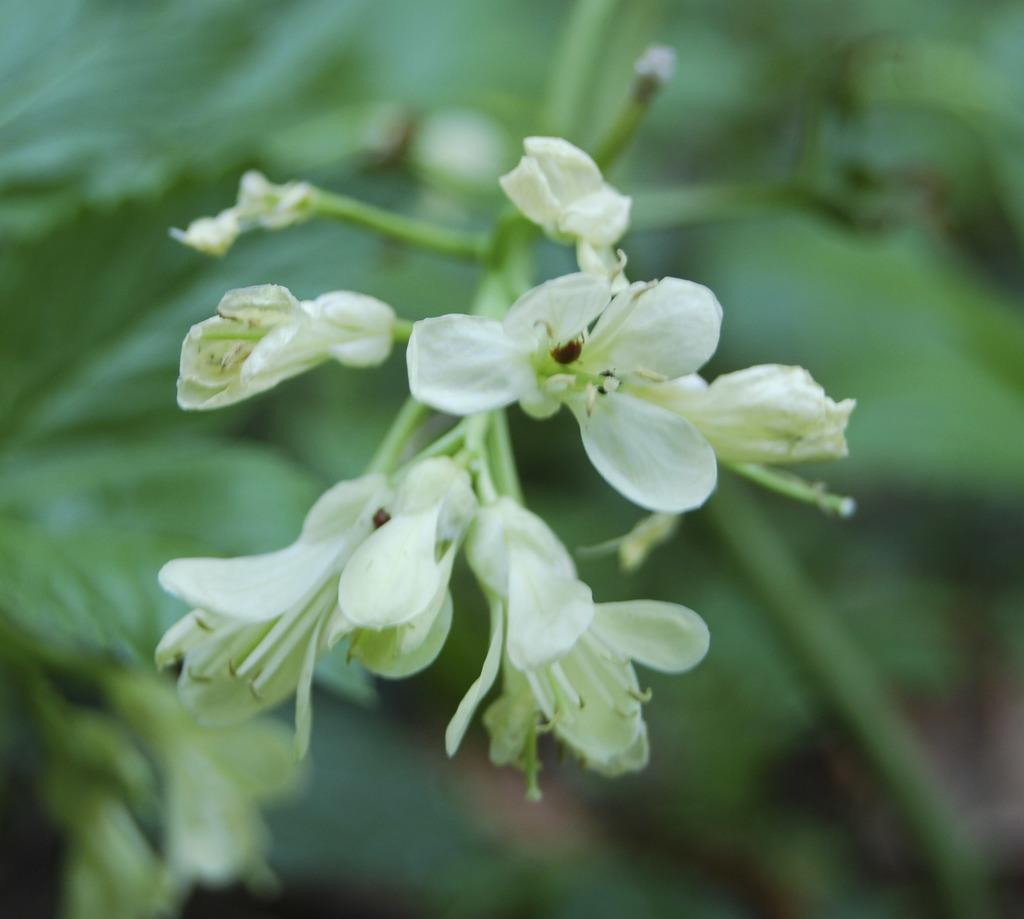What type of living organisms can be seen in the image? There are flowers in the image. Can you describe the background of the image? The background of the image is blurred. What type of card can be seen being used for learning in the image? There is no card or learning activity present in the image; it only features flowers and a blurred background. 